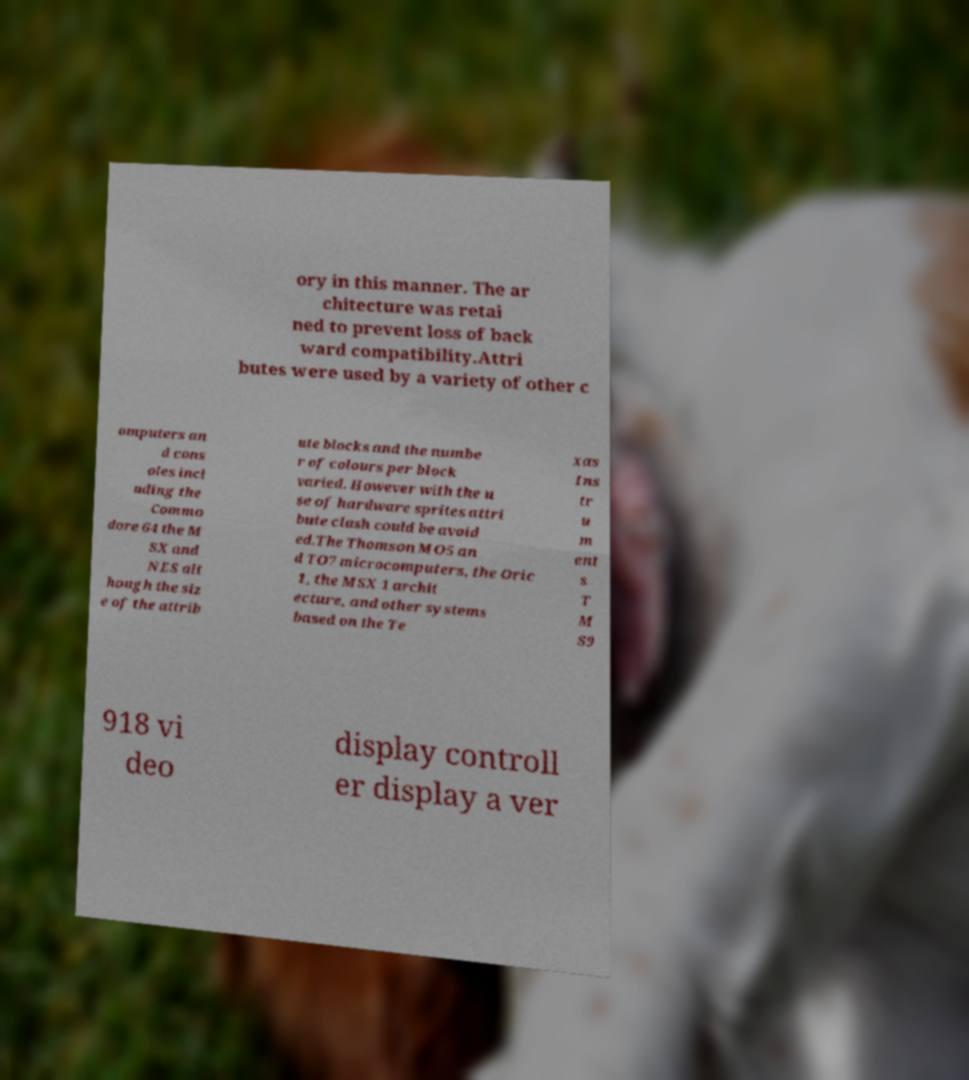I need the written content from this picture converted into text. Can you do that? ory in this manner. The ar chitecture was retai ned to prevent loss of back ward compatibility.Attri butes were used by a variety of other c omputers an d cons oles incl uding the Commo dore 64 the M SX and NES alt hough the siz e of the attrib ute blocks and the numbe r of colours per block varied. However with the u se of hardware sprites attri bute clash could be avoid ed.The Thomson MO5 an d TO7 microcomputers, the Oric 1, the MSX 1 archit ecture, and other systems based on the Te xas Ins tr u m ent s T M S9 918 vi deo display controll er display a ver 